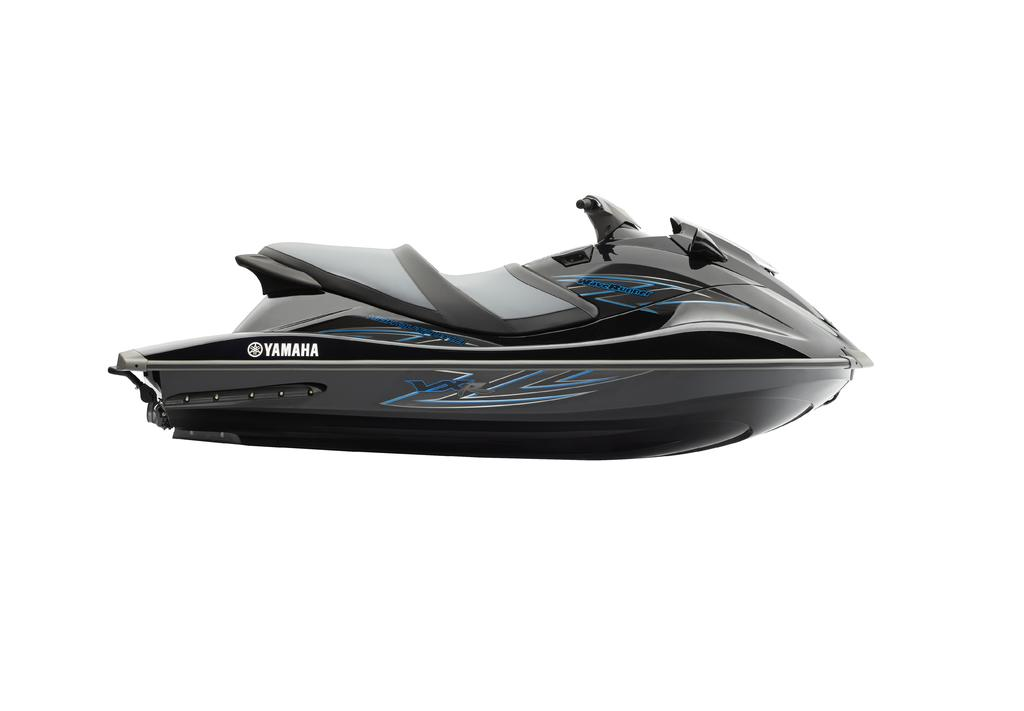What is the main subject in the center of the image? There is a jet ski in the center of the image. What type of butter is being used to limit the speed of the jet ski in the image? There is no butter or speed limitation mentioned in the image; it simply features a jet ski. 